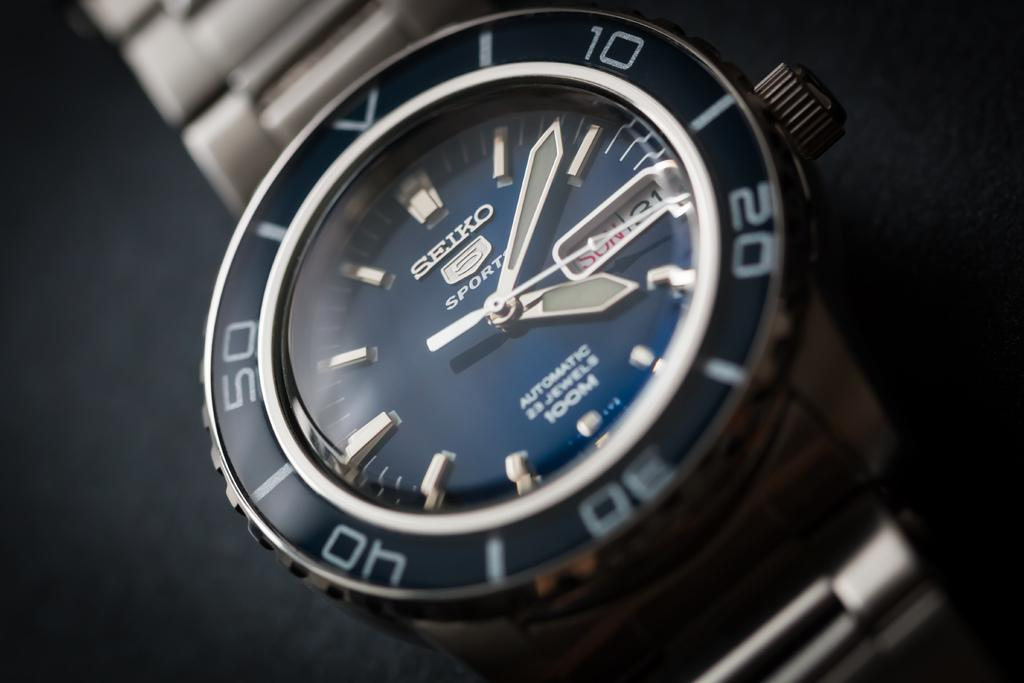What object is the main focus of the image? There is a wrist watch in the image. Can you describe the background of the image? The background of the image is blurry. Where is the cactus located in the image? There is no cactus present in the image. What type of legal advice is the lawyer providing in the image? There is no lawyer present in the image. 